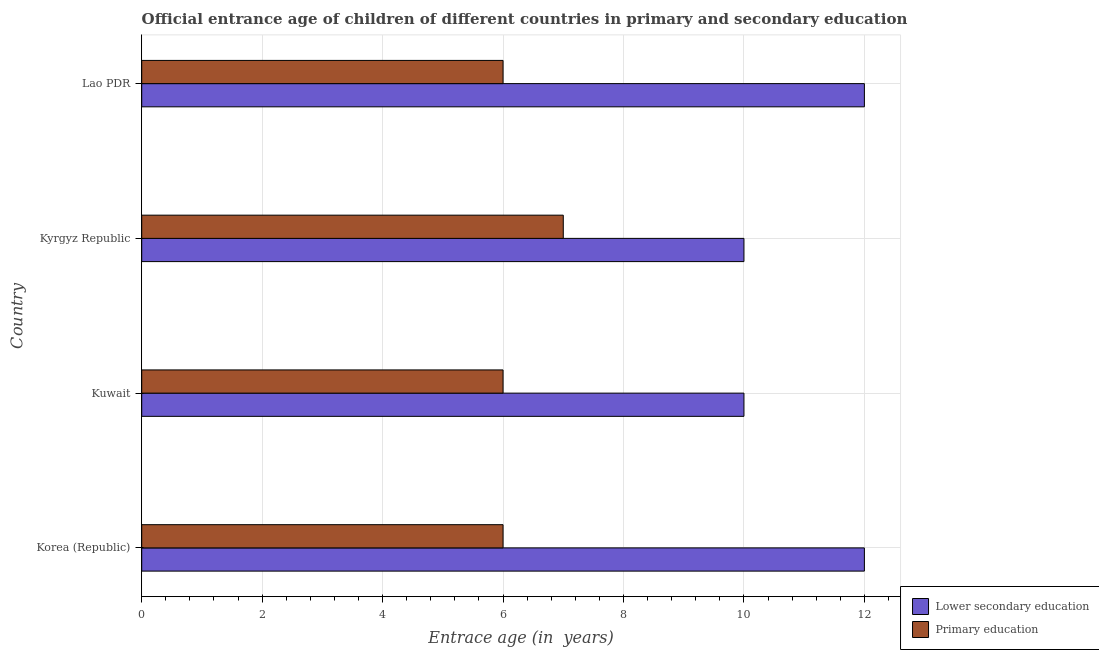How many different coloured bars are there?
Keep it short and to the point. 2. How many groups of bars are there?
Provide a short and direct response. 4. What is the label of the 1st group of bars from the top?
Keep it short and to the point. Lao PDR. In how many cases, is the number of bars for a given country not equal to the number of legend labels?
Provide a short and direct response. 0. What is the entrance age of children in lower secondary education in Lao PDR?
Offer a very short reply. 12. Across all countries, what is the maximum entrance age of children in lower secondary education?
Provide a succinct answer. 12. In which country was the entrance age of chiildren in primary education maximum?
Make the answer very short. Kyrgyz Republic. In which country was the entrance age of children in lower secondary education minimum?
Keep it short and to the point. Kuwait. What is the total entrance age of chiildren in primary education in the graph?
Offer a very short reply. 25. What is the difference between the entrance age of children in lower secondary education in Korea (Republic) and that in Kuwait?
Offer a terse response. 2. What is the difference between the entrance age of children in lower secondary education in Kyrgyz Republic and the entrance age of chiildren in primary education in Lao PDR?
Provide a succinct answer. 4. What is the average entrance age of chiildren in primary education per country?
Give a very brief answer. 6.25. In how many countries, is the entrance age of children in lower secondary education greater than 6 years?
Offer a terse response. 4. Is the difference between the entrance age of chiildren in primary education in Kyrgyz Republic and Lao PDR greater than the difference between the entrance age of children in lower secondary education in Kyrgyz Republic and Lao PDR?
Ensure brevity in your answer.  Yes. What is the difference between the highest and the lowest entrance age of children in lower secondary education?
Offer a terse response. 2. What does the 1st bar from the top in Kuwait represents?
Keep it short and to the point. Primary education. What does the 1st bar from the bottom in Lao PDR represents?
Provide a short and direct response. Lower secondary education. Does the graph contain any zero values?
Your answer should be compact. No. How are the legend labels stacked?
Ensure brevity in your answer.  Vertical. What is the title of the graph?
Provide a short and direct response. Official entrance age of children of different countries in primary and secondary education. What is the label or title of the X-axis?
Make the answer very short. Entrace age (in  years). What is the label or title of the Y-axis?
Your answer should be very brief. Country. What is the Entrace age (in  years) in Lower secondary education in Kuwait?
Provide a succinct answer. 10. What is the Entrace age (in  years) in Primary education in Kyrgyz Republic?
Your answer should be compact. 7. What is the Entrace age (in  years) of Lower secondary education in Lao PDR?
Give a very brief answer. 12. What is the Entrace age (in  years) of Primary education in Lao PDR?
Ensure brevity in your answer.  6. Across all countries, what is the maximum Entrace age (in  years) in Lower secondary education?
Your answer should be compact. 12. Across all countries, what is the maximum Entrace age (in  years) of Primary education?
Your answer should be compact. 7. Across all countries, what is the minimum Entrace age (in  years) of Lower secondary education?
Your answer should be very brief. 10. What is the total Entrace age (in  years) in Lower secondary education in the graph?
Provide a short and direct response. 44. What is the difference between the Entrace age (in  years) of Lower secondary education in Korea (Republic) and that in Kuwait?
Your answer should be very brief. 2. What is the difference between the Entrace age (in  years) in Primary education in Korea (Republic) and that in Kyrgyz Republic?
Make the answer very short. -1. What is the difference between the Entrace age (in  years) of Lower secondary education in Korea (Republic) and that in Lao PDR?
Make the answer very short. 0. What is the difference between the Entrace age (in  years) of Primary education in Korea (Republic) and that in Lao PDR?
Give a very brief answer. 0. What is the difference between the Entrace age (in  years) of Lower secondary education in Kuwait and that in Lao PDR?
Offer a terse response. -2. What is the difference between the Entrace age (in  years) in Primary education in Kuwait and that in Lao PDR?
Give a very brief answer. 0. What is the difference between the Entrace age (in  years) in Lower secondary education in Korea (Republic) and the Entrace age (in  years) in Primary education in Kuwait?
Give a very brief answer. 6. What is the difference between the Entrace age (in  years) of Lower secondary education in Korea (Republic) and the Entrace age (in  years) of Primary education in Lao PDR?
Your response must be concise. 6. What is the difference between the Entrace age (in  years) of Lower secondary education in Kuwait and the Entrace age (in  years) of Primary education in Kyrgyz Republic?
Your response must be concise. 3. What is the difference between the Entrace age (in  years) in Lower secondary education in Kuwait and the Entrace age (in  years) in Primary education in Lao PDR?
Provide a succinct answer. 4. What is the difference between the Entrace age (in  years) of Lower secondary education in Kyrgyz Republic and the Entrace age (in  years) of Primary education in Lao PDR?
Give a very brief answer. 4. What is the average Entrace age (in  years) of Lower secondary education per country?
Your answer should be very brief. 11. What is the average Entrace age (in  years) of Primary education per country?
Your response must be concise. 6.25. What is the difference between the Entrace age (in  years) in Lower secondary education and Entrace age (in  years) in Primary education in Korea (Republic)?
Ensure brevity in your answer.  6. What is the ratio of the Entrace age (in  years) in Lower secondary education in Korea (Republic) to that in Kuwait?
Provide a succinct answer. 1.2. What is the ratio of the Entrace age (in  years) in Lower secondary education in Korea (Republic) to that in Lao PDR?
Your response must be concise. 1. What is the ratio of the Entrace age (in  years) in Primary education in Korea (Republic) to that in Lao PDR?
Keep it short and to the point. 1. What is the ratio of the Entrace age (in  years) in Lower secondary education in Kyrgyz Republic to that in Lao PDR?
Keep it short and to the point. 0.83. What is the ratio of the Entrace age (in  years) in Primary education in Kyrgyz Republic to that in Lao PDR?
Give a very brief answer. 1.17. What is the difference between the highest and the lowest Entrace age (in  years) in Primary education?
Your answer should be compact. 1. 